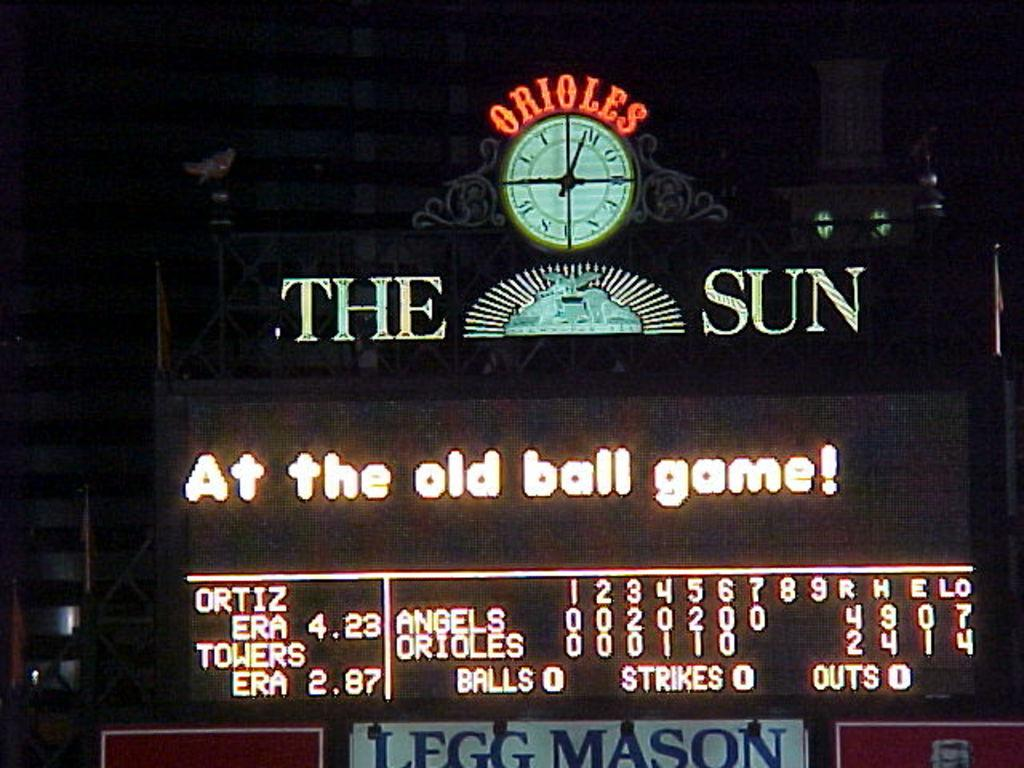What is the main structure in the image? There is a building in the image. What feature is present in the middle of the building? The building has a clock in the middle. What is located below the clock? There is a scroll board below the clock. What type of jewel is displayed on the scroll board in the image? There is no jewel present on the scroll board in the image. What type of love story is depicted on the scroll board in the image? There is no love story or any reference to love on the scroll board in the image. 